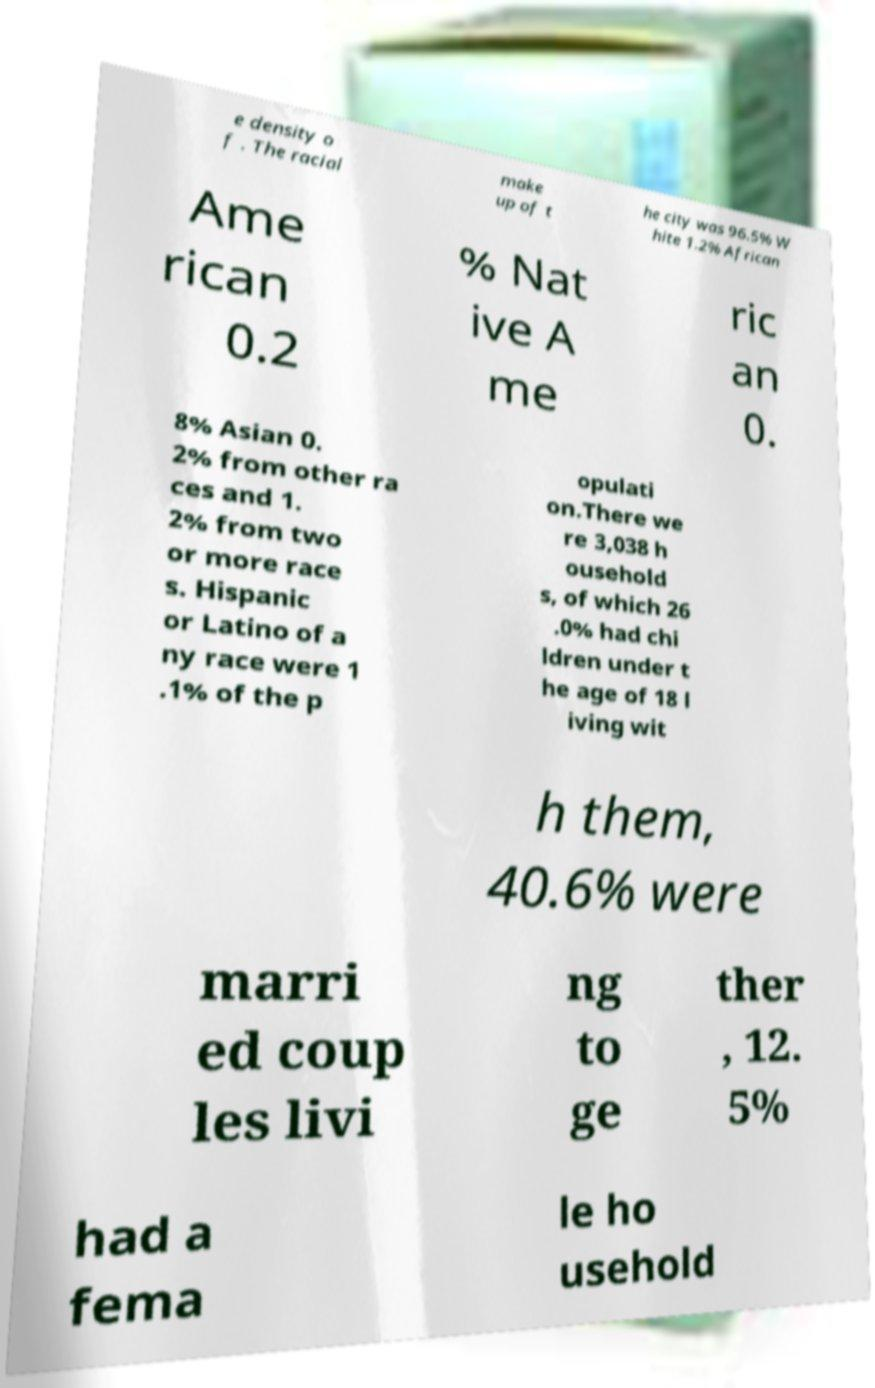There's text embedded in this image that I need extracted. Can you transcribe it verbatim? e density o f . The racial make up of t he city was 96.5% W hite 1.2% African Ame rican 0.2 % Nat ive A me ric an 0. 8% Asian 0. 2% from other ra ces and 1. 2% from two or more race s. Hispanic or Latino of a ny race were 1 .1% of the p opulati on.There we re 3,038 h ousehold s, of which 26 .0% had chi ldren under t he age of 18 l iving wit h them, 40.6% were marri ed coup les livi ng to ge ther , 12. 5% had a fema le ho usehold 